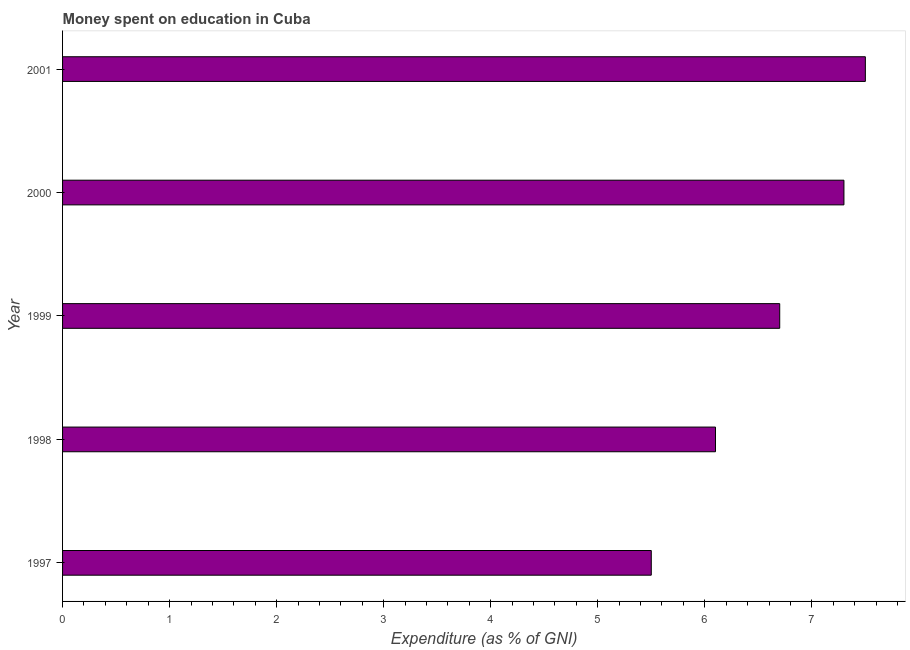Does the graph contain grids?
Your answer should be compact. No. What is the title of the graph?
Offer a terse response. Money spent on education in Cuba. What is the label or title of the X-axis?
Provide a succinct answer. Expenditure (as % of GNI). Across all years, what is the minimum expenditure on education?
Your answer should be very brief. 5.5. In which year was the expenditure on education maximum?
Your answer should be very brief. 2001. In which year was the expenditure on education minimum?
Provide a short and direct response. 1997. What is the sum of the expenditure on education?
Provide a succinct answer. 33.1. What is the average expenditure on education per year?
Offer a very short reply. 6.62. What is the median expenditure on education?
Ensure brevity in your answer.  6.7. Do a majority of the years between 2000 and 1997 (inclusive) have expenditure on education greater than 0.8 %?
Your answer should be very brief. Yes. What is the ratio of the expenditure on education in 1997 to that in 2000?
Your response must be concise. 0.75. What is the difference between the highest and the second highest expenditure on education?
Give a very brief answer. 0.2. Is the sum of the expenditure on education in 1998 and 2001 greater than the maximum expenditure on education across all years?
Provide a short and direct response. Yes. What is the difference between the highest and the lowest expenditure on education?
Make the answer very short. 2. How many bars are there?
Make the answer very short. 5. How many years are there in the graph?
Keep it short and to the point. 5. Are the values on the major ticks of X-axis written in scientific E-notation?
Offer a terse response. No. What is the Expenditure (as % of GNI) in 1997?
Offer a very short reply. 5.5. What is the Expenditure (as % of GNI) in 1998?
Provide a short and direct response. 6.1. What is the Expenditure (as % of GNI) of 1999?
Give a very brief answer. 6.7. What is the Expenditure (as % of GNI) of 2001?
Offer a very short reply. 7.5. What is the difference between the Expenditure (as % of GNI) in 1997 and 1998?
Offer a very short reply. -0.6. What is the difference between the Expenditure (as % of GNI) in 1997 and 1999?
Keep it short and to the point. -1.2. What is the difference between the Expenditure (as % of GNI) in 1998 and 1999?
Offer a terse response. -0.6. What is the difference between the Expenditure (as % of GNI) in 1998 and 2000?
Provide a succinct answer. -1.2. What is the difference between the Expenditure (as % of GNI) in 1998 and 2001?
Keep it short and to the point. -1.4. What is the difference between the Expenditure (as % of GNI) in 1999 and 2000?
Give a very brief answer. -0.6. What is the difference between the Expenditure (as % of GNI) in 1999 and 2001?
Your answer should be very brief. -0.8. What is the ratio of the Expenditure (as % of GNI) in 1997 to that in 1998?
Make the answer very short. 0.9. What is the ratio of the Expenditure (as % of GNI) in 1997 to that in 1999?
Keep it short and to the point. 0.82. What is the ratio of the Expenditure (as % of GNI) in 1997 to that in 2000?
Offer a very short reply. 0.75. What is the ratio of the Expenditure (as % of GNI) in 1997 to that in 2001?
Provide a succinct answer. 0.73. What is the ratio of the Expenditure (as % of GNI) in 1998 to that in 1999?
Provide a short and direct response. 0.91. What is the ratio of the Expenditure (as % of GNI) in 1998 to that in 2000?
Your response must be concise. 0.84. What is the ratio of the Expenditure (as % of GNI) in 1998 to that in 2001?
Provide a short and direct response. 0.81. What is the ratio of the Expenditure (as % of GNI) in 1999 to that in 2000?
Your answer should be very brief. 0.92. What is the ratio of the Expenditure (as % of GNI) in 1999 to that in 2001?
Keep it short and to the point. 0.89. 